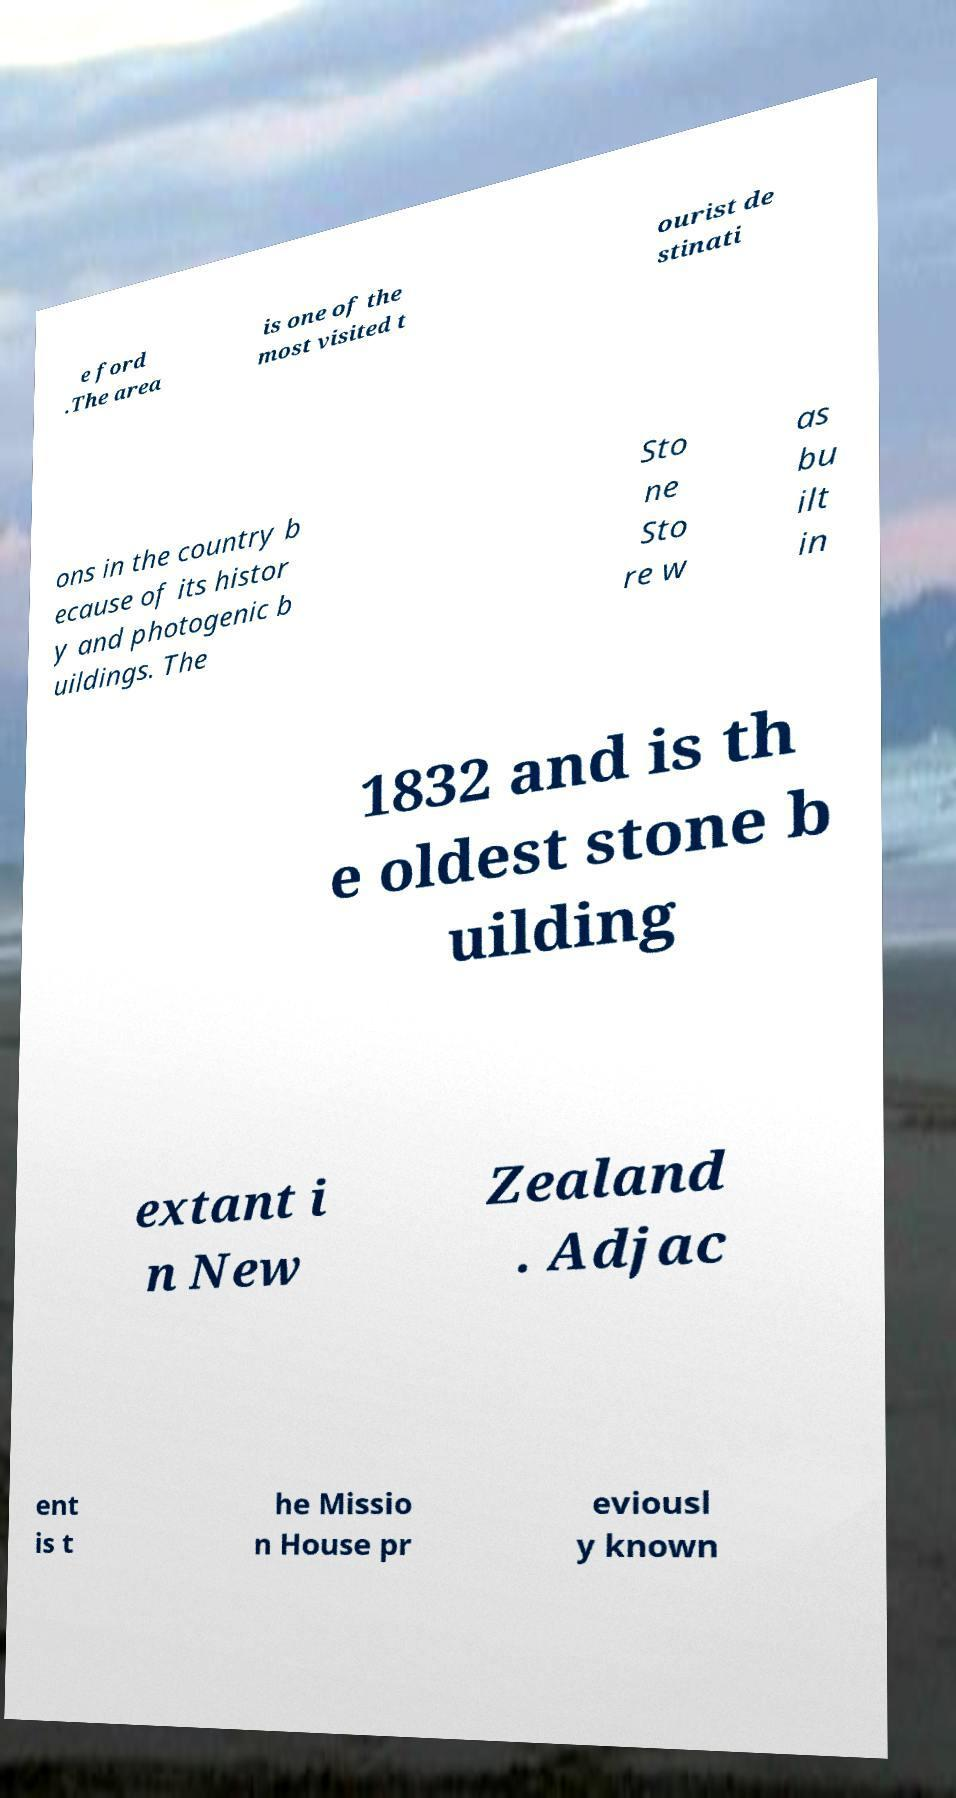I need the written content from this picture converted into text. Can you do that? e ford .The area is one of the most visited t ourist de stinati ons in the country b ecause of its histor y and photogenic b uildings. The Sto ne Sto re w as bu ilt in 1832 and is th e oldest stone b uilding extant i n New Zealand . Adjac ent is t he Missio n House pr eviousl y known 